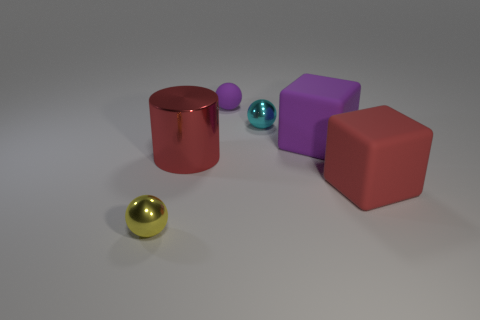Add 3 red cylinders. How many objects exist? 9 Subtract all cylinders. How many objects are left? 5 Subtract 1 red cylinders. How many objects are left? 5 Subtract all tiny balls. Subtract all red metallic spheres. How many objects are left? 3 Add 4 big metal objects. How many big metal objects are left? 5 Add 5 red matte objects. How many red matte objects exist? 6 